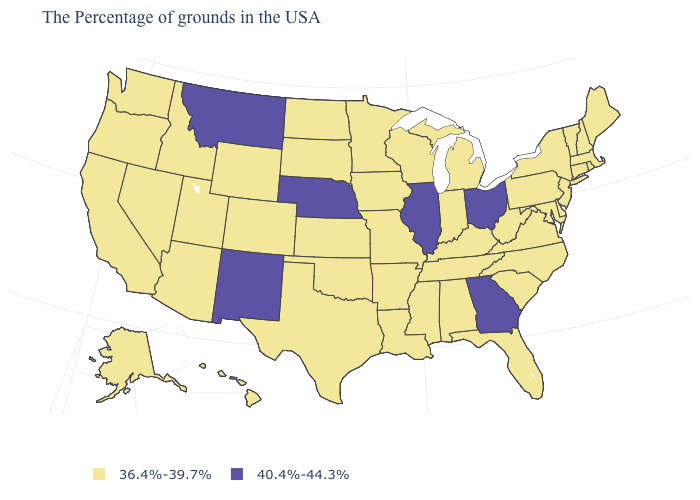What is the value of New York?
Concise answer only. 36.4%-39.7%. What is the value of Connecticut?
Short answer required. 36.4%-39.7%. Among the states that border Rhode Island , which have the highest value?
Quick response, please. Massachusetts, Connecticut. Does Nebraska have the lowest value in the MidWest?
Concise answer only. No. What is the value of Kansas?
Short answer required. 36.4%-39.7%. Name the states that have a value in the range 36.4%-39.7%?
Concise answer only. Maine, Massachusetts, Rhode Island, New Hampshire, Vermont, Connecticut, New York, New Jersey, Delaware, Maryland, Pennsylvania, Virginia, North Carolina, South Carolina, West Virginia, Florida, Michigan, Kentucky, Indiana, Alabama, Tennessee, Wisconsin, Mississippi, Louisiana, Missouri, Arkansas, Minnesota, Iowa, Kansas, Oklahoma, Texas, South Dakota, North Dakota, Wyoming, Colorado, Utah, Arizona, Idaho, Nevada, California, Washington, Oregon, Alaska, Hawaii. What is the lowest value in the USA?
Keep it brief. 36.4%-39.7%. Does Alabama have the highest value in the USA?
Quick response, please. No. Among the states that border Missouri , does Kansas have the highest value?
Answer briefly. No. Does Montana have the lowest value in the USA?
Give a very brief answer. No. Among the states that border West Virginia , does Ohio have the highest value?
Give a very brief answer. Yes. Among the states that border Pennsylvania , does West Virginia have the highest value?
Keep it brief. No. What is the value of Illinois?
Give a very brief answer. 40.4%-44.3%. Among the states that border Virginia , which have the highest value?
Give a very brief answer. Maryland, North Carolina, West Virginia, Kentucky, Tennessee. Among the states that border Wyoming , does Montana have the highest value?
Keep it brief. Yes. 